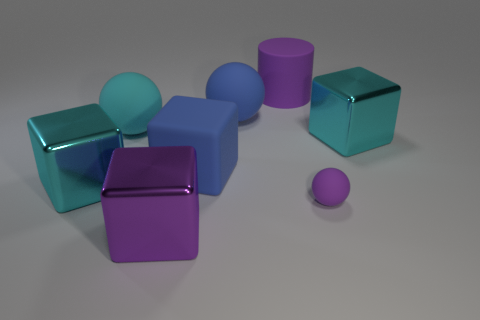Subtract 2 blocks. How many blocks are left? 2 Add 2 blue metallic cylinders. How many objects exist? 10 Subtract all cylinders. How many objects are left? 7 Subtract all large blue cubes. Subtract all big rubber cylinders. How many objects are left? 6 Add 8 big purple blocks. How many big purple blocks are left? 9 Add 2 blue rubber blocks. How many blue rubber blocks exist? 3 Subtract 0 yellow cubes. How many objects are left? 8 